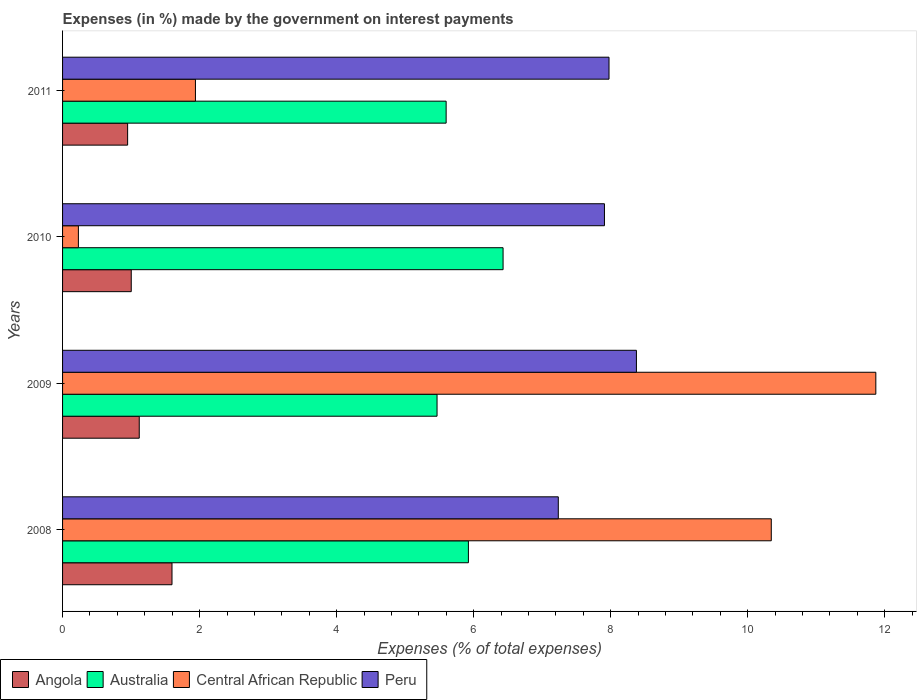Are the number of bars per tick equal to the number of legend labels?
Make the answer very short. Yes. How many bars are there on the 4th tick from the top?
Your response must be concise. 4. What is the percentage of expenses made by the government on interest payments in Angola in 2009?
Provide a succinct answer. 1.12. Across all years, what is the maximum percentage of expenses made by the government on interest payments in Angola?
Your response must be concise. 1.6. Across all years, what is the minimum percentage of expenses made by the government on interest payments in Central African Republic?
Offer a terse response. 0.23. In which year was the percentage of expenses made by the government on interest payments in Peru maximum?
Offer a very short reply. 2009. In which year was the percentage of expenses made by the government on interest payments in Australia minimum?
Give a very brief answer. 2009. What is the total percentage of expenses made by the government on interest payments in Central African Republic in the graph?
Your answer should be very brief. 24.38. What is the difference between the percentage of expenses made by the government on interest payments in Angola in 2010 and that in 2011?
Offer a very short reply. 0.05. What is the difference between the percentage of expenses made by the government on interest payments in Peru in 2010 and the percentage of expenses made by the government on interest payments in Australia in 2011?
Your answer should be very brief. 2.31. What is the average percentage of expenses made by the government on interest payments in Australia per year?
Provide a short and direct response. 5.85. In the year 2009, what is the difference between the percentage of expenses made by the government on interest payments in Central African Republic and percentage of expenses made by the government on interest payments in Australia?
Keep it short and to the point. 6.4. What is the ratio of the percentage of expenses made by the government on interest payments in Central African Republic in 2008 to that in 2010?
Your answer should be very brief. 44.79. Is the percentage of expenses made by the government on interest payments in Peru in 2008 less than that in 2011?
Your answer should be very brief. Yes. Is the difference between the percentage of expenses made by the government on interest payments in Central African Republic in 2009 and 2011 greater than the difference between the percentage of expenses made by the government on interest payments in Australia in 2009 and 2011?
Provide a short and direct response. Yes. What is the difference between the highest and the second highest percentage of expenses made by the government on interest payments in Central African Republic?
Your answer should be very brief. 1.53. What is the difference between the highest and the lowest percentage of expenses made by the government on interest payments in Australia?
Provide a succinct answer. 0.96. In how many years, is the percentage of expenses made by the government on interest payments in Peru greater than the average percentage of expenses made by the government on interest payments in Peru taken over all years?
Ensure brevity in your answer.  3. Is it the case that in every year, the sum of the percentage of expenses made by the government on interest payments in Peru and percentage of expenses made by the government on interest payments in Australia is greater than the sum of percentage of expenses made by the government on interest payments in Angola and percentage of expenses made by the government on interest payments in Central African Republic?
Ensure brevity in your answer.  Yes. What does the 3rd bar from the top in 2008 represents?
Your answer should be very brief. Australia. What does the 4th bar from the bottom in 2008 represents?
Ensure brevity in your answer.  Peru. Are all the bars in the graph horizontal?
Provide a short and direct response. Yes. How many years are there in the graph?
Provide a short and direct response. 4. What is the difference between two consecutive major ticks on the X-axis?
Give a very brief answer. 2. Are the values on the major ticks of X-axis written in scientific E-notation?
Ensure brevity in your answer.  No. Where does the legend appear in the graph?
Provide a succinct answer. Bottom left. What is the title of the graph?
Ensure brevity in your answer.  Expenses (in %) made by the government on interest payments. Does "Lower middle income" appear as one of the legend labels in the graph?
Your answer should be compact. No. What is the label or title of the X-axis?
Your response must be concise. Expenses (% of total expenses). What is the label or title of the Y-axis?
Give a very brief answer. Years. What is the Expenses (% of total expenses) of Angola in 2008?
Your answer should be compact. 1.6. What is the Expenses (% of total expenses) of Australia in 2008?
Ensure brevity in your answer.  5.92. What is the Expenses (% of total expenses) in Central African Republic in 2008?
Your response must be concise. 10.34. What is the Expenses (% of total expenses) in Peru in 2008?
Your answer should be very brief. 7.24. What is the Expenses (% of total expenses) of Angola in 2009?
Your answer should be very brief. 1.12. What is the Expenses (% of total expenses) of Australia in 2009?
Offer a very short reply. 5.47. What is the Expenses (% of total expenses) in Central African Republic in 2009?
Keep it short and to the point. 11.87. What is the Expenses (% of total expenses) in Peru in 2009?
Provide a succinct answer. 8.38. What is the Expenses (% of total expenses) in Angola in 2010?
Offer a terse response. 1. What is the Expenses (% of total expenses) in Australia in 2010?
Provide a succinct answer. 6.43. What is the Expenses (% of total expenses) in Central African Republic in 2010?
Make the answer very short. 0.23. What is the Expenses (% of total expenses) of Peru in 2010?
Give a very brief answer. 7.91. What is the Expenses (% of total expenses) in Angola in 2011?
Your answer should be compact. 0.95. What is the Expenses (% of total expenses) of Australia in 2011?
Make the answer very short. 5.6. What is the Expenses (% of total expenses) of Central African Republic in 2011?
Make the answer very short. 1.94. What is the Expenses (% of total expenses) of Peru in 2011?
Offer a terse response. 7.98. Across all years, what is the maximum Expenses (% of total expenses) in Angola?
Offer a very short reply. 1.6. Across all years, what is the maximum Expenses (% of total expenses) of Australia?
Provide a succinct answer. 6.43. Across all years, what is the maximum Expenses (% of total expenses) of Central African Republic?
Your answer should be very brief. 11.87. Across all years, what is the maximum Expenses (% of total expenses) of Peru?
Your answer should be very brief. 8.38. Across all years, what is the minimum Expenses (% of total expenses) of Angola?
Make the answer very short. 0.95. Across all years, what is the minimum Expenses (% of total expenses) in Australia?
Your answer should be compact. 5.47. Across all years, what is the minimum Expenses (% of total expenses) of Central African Republic?
Keep it short and to the point. 0.23. Across all years, what is the minimum Expenses (% of total expenses) in Peru?
Your answer should be very brief. 7.24. What is the total Expenses (% of total expenses) in Angola in the graph?
Offer a very short reply. 4.67. What is the total Expenses (% of total expenses) in Australia in the graph?
Make the answer very short. 23.42. What is the total Expenses (% of total expenses) of Central African Republic in the graph?
Provide a succinct answer. 24.38. What is the total Expenses (% of total expenses) in Peru in the graph?
Give a very brief answer. 31.5. What is the difference between the Expenses (% of total expenses) in Angola in 2008 and that in 2009?
Ensure brevity in your answer.  0.48. What is the difference between the Expenses (% of total expenses) in Australia in 2008 and that in 2009?
Keep it short and to the point. 0.46. What is the difference between the Expenses (% of total expenses) in Central African Republic in 2008 and that in 2009?
Offer a terse response. -1.53. What is the difference between the Expenses (% of total expenses) in Peru in 2008 and that in 2009?
Your answer should be very brief. -1.14. What is the difference between the Expenses (% of total expenses) of Angola in 2008 and that in 2010?
Provide a short and direct response. 0.59. What is the difference between the Expenses (% of total expenses) of Australia in 2008 and that in 2010?
Provide a succinct answer. -0.51. What is the difference between the Expenses (% of total expenses) of Central African Republic in 2008 and that in 2010?
Make the answer very short. 10.11. What is the difference between the Expenses (% of total expenses) in Peru in 2008 and that in 2010?
Your response must be concise. -0.67. What is the difference between the Expenses (% of total expenses) of Angola in 2008 and that in 2011?
Keep it short and to the point. 0.65. What is the difference between the Expenses (% of total expenses) in Australia in 2008 and that in 2011?
Offer a terse response. 0.33. What is the difference between the Expenses (% of total expenses) of Central African Republic in 2008 and that in 2011?
Your answer should be compact. 8.4. What is the difference between the Expenses (% of total expenses) in Peru in 2008 and that in 2011?
Offer a very short reply. -0.74. What is the difference between the Expenses (% of total expenses) of Angola in 2009 and that in 2010?
Provide a succinct answer. 0.12. What is the difference between the Expenses (% of total expenses) in Australia in 2009 and that in 2010?
Your response must be concise. -0.96. What is the difference between the Expenses (% of total expenses) of Central African Republic in 2009 and that in 2010?
Keep it short and to the point. 11.64. What is the difference between the Expenses (% of total expenses) of Peru in 2009 and that in 2010?
Your response must be concise. 0.47. What is the difference between the Expenses (% of total expenses) in Angola in 2009 and that in 2011?
Ensure brevity in your answer.  0.17. What is the difference between the Expenses (% of total expenses) of Australia in 2009 and that in 2011?
Offer a very short reply. -0.13. What is the difference between the Expenses (% of total expenses) in Central African Republic in 2009 and that in 2011?
Keep it short and to the point. 9.93. What is the difference between the Expenses (% of total expenses) of Peru in 2009 and that in 2011?
Offer a very short reply. 0.4. What is the difference between the Expenses (% of total expenses) in Angola in 2010 and that in 2011?
Your answer should be compact. 0.05. What is the difference between the Expenses (% of total expenses) of Australia in 2010 and that in 2011?
Offer a very short reply. 0.83. What is the difference between the Expenses (% of total expenses) in Central African Republic in 2010 and that in 2011?
Your response must be concise. -1.71. What is the difference between the Expenses (% of total expenses) of Peru in 2010 and that in 2011?
Keep it short and to the point. -0.07. What is the difference between the Expenses (% of total expenses) of Angola in 2008 and the Expenses (% of total expenses) of Australia in 2009?
Your answer should be compact. -3.87. What is the difference between the Expenses (% of total expenses) in Angola in 2008 and the Expenses (% of total expenses) in Central African Republic in 2009?
Ensure brevity in your answer.  -10.27. What is the difference between the Expenses (% of total expenses) in Angola in 2008 and the Expenses (% of total expenses) in Peru in 2009?
Provide a short and direct response. -6.78. What is the difference between the Expenses (% of total expenses) in Australia in 2008 and the Expenses (% of total expenses) in Central African Republic in 2009?
Your answer should be compact. -5.95. What is the difference between the Expenses (% of total expenses) in Australia in 2008 and the Expenses (% of total expenses) in Peru in 2009?
Keep it short and to the point. -2.45. What is the difference between the Expenses (% of total expenses) of Central African Republic in 2008 and the Expenses (% of total expenses) of Peru in 2009?
Provide a succinct answer. 1.97. What is the difference between the Expenses (% of total expenses) in Angola in 2008 and the Expenses (% of total expenses) in Australia in 2010?
Your response must be concise. -4.83. What is the difference between the Expenses (% of total expenses) in Angola in 2008 and the Expenses (% of total expenses) in Central African Republic in 2010?
Make the answer very short. 1.37. What is the difference between the Expenses (% of total expenses) in Angola in 2008 and the Expenses (% of total expenses) in Peru in 2010?
Provide a succinct answer. -6.31. What is the difference between the Expenses (% of total expenses) of Australia in 2008 and the Expenses (% of total expenses) of Central African Republic in 2010?
Offer a terse response. 5.69. What is the difference between the Expenses (% of total expenses) of Australia in 2008 and the Expenses (% of total expenses) of Peru in 2010?
Provide a succinct answer. -1.99. What is the difference between the Expenses (% of total expenses) of Central African Republic in 2008 and the Expenses (% of total expenses) of Peru in 2010?
Make the answer very short. 2.43. What is the difference between the Expenses (% of total expenses) in Angola in 2008 and the Expenses (% of total expenses) in Australia in 2011?
Your answer should be very brief. -4. What is the difference between the Expenses (% of total expenses) of Angola in 2008 and the Expenses (% of total expenses) of Central African Republic in 2011?
Your answer should be very brief. -0.34. What is the difference between the Expenses (% of total expenses) of Angola in 2008 and the Expenses (% of total expenses) of Peru in 2011?
Provide a succinct answer. -6.38. What is the difference between the Expenses (% of total expenses) of Australia in 2008 and the Expenses (% of total expenses) of Central African Republic in 2011?
Give a very brief answer. 3.98. What is the difference between the Expenses (% of total expenses) in Australia in 2008 and the Expenses (% of total expenses) in Peru in 2011?
Give a very brief answer. -2.05. What is the difference between the Expenses (% of total expenses) of Central African Republic in 2008 and the Expenses (% of total expenses) of Peru in 2011?
Offer a very short reply. 2.37. What is the difference between the Expenses (% of total expenses) of Angola in 2009 and the Expenses (% of total expenses) of Australia in 2010?
Offer a terse response. -5.31. What is the difference between the Expenses (% of total expenses) in Angola in 2009 and the Expenses (% of total expenses) in Central African Republic in 2010?
Keep it short and to the point. 0.89. What is the difference between the Expenses (% of total expenses) of Angola in 2009 and the Expenses (% of total expenses) of Peru in 2010?
Give a very brief answer. -6.79. What is the difference between the Expenses (% of total expenses) in Australia in 2009 and the Expenses (% of total expenses) in Central African Republic in 2010?
Make the answer very short. 5.23. What is the difference between the Expenses (% of total expenses) in Australia in 2009 and the Expenses (% of total expenses) in Peru in 2010?
Your answer should be compact. -2.44. What is the difference between the Expenses (% of total expenses) of Central African Republic in 2009 and the Expenses (% of total expenses) of Peru in 2010?
Your answer should be compact. 3.96. What is the difference between the Expenses (% of total expenses) in Angola in 2009 and the Expenses (% of total expenses) in Australia in 2011?
Keep it short and to the point. -4.48. What is the difference between the Expenses (% of total expenses) in Angola in 2009 and the Expenses (% of total expenses) in Central African Republic in 2011?
Keep it short and to the point. -0.82. What is the difference between the Expenses (% of total expenses) of Angola in 2009 and the Expenses (% of total expenses) of Peru in 2011?
Provide a short and direct response. -6.86. What is the difference between the Expenses (% of total expenses) in Australia in 2009 and the Expenses (% of total expenses) in Central African Republic in 2011?
Keep it short and to the point. 3.53. What is the difference between the Expenses (% of total expenses) of Australia in 2009 and the Expenses (% of total expenses) of Peru in 2011?
Make the answer very short. -2.51. What is the difference between the Expenses (% of total expenses) of Central African Republic in 2009 and the Expenses (% of total expenses) of Peru in 2011?
Your answer should be very brief. 3.89. What is the difference between the Expenses (% of total expenses) of Angola in 2010 and the Expenses (% of total expenses) of Australia in 2011?
Your answer should be compact. -4.6. What is the difference between the Expenses (% of total expenses) in Angola in 2010 and the Expenses (% of total expenses) in Central African Republic in 2011?
Your response must be concise. -0.94. What is the difference between the Expenses (% of total expenses) of Angola in 2010 and the Expenses (% of total expenses) of Peru in 2011?
Your answer should be compact. -6.97. What is the difference between the Expenses (% of total expenses) of Australia in 2010 and the Expenses (% of total expenses) of Central African Republic in 2011?
Offer a terse response. 4.49. What is the difference between the Expenses (% of total expenses) in Australia in 2010 and the Expenses (% of total expenses) in Peru in 2011?
Your response must be concise. -1.55. What is the difference between the Expenses (% of total expenses) of Central African Republic in 2010 and the Expenses (% of total expenses) of Peru in 2011?
Your answer should be very brief. -7.74. What is the average Expenses (% of total expenses) of Angola per year?
Keep it short and to the point. 1.17. What is the average Expenses (% of total expenses) of Australia per year?
Provide a short and direct response. 5.85. What is the average Expenses (% of total expenses) in Central African Republic per year?
Provide a short and direct response. 6.1. What is the average Expenses (% of total expenses) of Peru per year?
Your answer should be compact. 7.87. In the year 2008, what is the difference between the Expenses (% of total expenses) of Angola and Expenses (% of total expenses) of Australia?
Your response must be concise. -4.33. In the year 2008, what is the difference between the Expenses (% of total expenses) of Angola and Expenses (% of total expenses) of Central African Republic?
Offer a terse response. -8.75. In the year 2008, what is the difference between the Expenses (% of total expenses) of Angola and Expenses (% of total expenses) of Peru?
Offer a very short reply. -5.64. In the year 2008, what is the difference between the Expenses (% of total expenses) in Australia and Expenses (% of total expenses) in Central African Republic?
Provide a short and direct response. -4.42. In the year 2008, what is the difference between the Expenses (% of total expenses) of Australia and Expenses (% of total expenses) of Peru?
Make the answer very short. -1.31. In the year 2008, what is the difference between the Expenses (% of total expenses) of Central African Republic and Expenses (% of total expenses) of Peru?
Make the answer very short. 3.11. In the year 2009, what is the difference between the Expenses (% of total expenses) in Angola and Expenses (% of total expenses) in Australia?
Your response must be concise. -4.35. In the year 2009, what is the difference between the Expenses (% of total expenses) in Angola and Expenses (% of total expenses) in Central African Republic?
Ensure brevity in your answer.  -10.75. In the year 2009, what is the difference between the Expenses (% of total expenses) in Angola and Expenses (% of total expenses) in Peru?
Your answer should be very brief. -7.26. In the year 2009, what is the difference between the Expenses (% of total expenses) of Australia and Expenses (% of total expenses) of Central African Republic?
Provide a succinct answer. -6.4. In the year 2009, what is the difference between the Expenses (% of total expenses) in Australia and Expenses (% of total expenses) in Peru?
Your answer should be very brief. -2.91. In the year 2009, what is the difference between the Expenses (% of total expenses) of Central African Republic and Expenses (% of total expenses) of Peru?
Your answer should be very brief. 3.49. In the year 2010, what is the difference between the Expenses (% of total expenses) in Angola and Expenses (% of total expenses) in Australia?
Make the answer very short. -5.43. In the year 2010, what is the difference between the Expenses (% of total expenses) in Angola and Expenses (% of total expenses) in Central African Republic?
Offer a very short reply. 0.77. In the year 2010, what is the difference between the Expenses (% of total expenses) in Angola and Expenses (% of total expenses) in Peru?
Offer a terse response. -6.91. In the year 2010, what is the difference between the Expenses (% of total expenses) in Australia and Expenses (% of total expenses) in Central African Republic?
Your answer should be very brief. 6.2. In the year 2010, what is the difference between the Expenses (% of total expenses) of Australia and Expenses (% of total expenses) of Peru?
Give a very brief answer. -1.48. In the year 2010, what is the difference between the Expenses (% of total expenses) of Central African Republic and Expenses (% of total expenses) of Peru?
Your answer should be very brief. -7.68. In the year 2011, what is the difference between the Expenses (% of total expenses) in Angola and Expenses (% of total expenses) in Australia?
Your answer should be very brief. -4.65. In the year 2011, what is the difference between the Expenses (% of total expenses) in Angola and Expenses (% of total expenses) in Central African Republic?
Offer a very short reply. -0.99. In the year 2011, what is the difference between the Expenses (% of total expenses) in Angola and Expenses (% of total expenses) in Peru?
Your response must be concise. -7.03. In the year 2011, what is the difference between the Expenses (% of total expenses) of Australia and Expenses (% of total expenses) of Central African Republic?
Provide a succinct answer. 3.66. In the year 2011, what is the difference between the Expenses (% of total expenses) of Australia and Expenses (% of total expenses) of Peru?
Offer a very short reply. -2.38. In the year 2011, what is the difference between the Expenses (% of total expenses) of Central African Republic and Expenses (% of total expenses) of Peru?
Provide a short and direct response. -6.04. What is the ratio of the Expenses (% of total expenses) of Angola in 2008 to that in 2009?
Make the answer very short. 1.43. What is the ratio of the Expenses (% of total expenses) in Australia in 2008 to that in 2009?
Provide a succinct answer. 1.08. What is the ratio of the Expenses (% of total expenses) of Central African Republic in 2008 to that in 2009?
Ensure brevity in your answer.  0.87. What is the ratio of the Expenses (% of total expenses) in Peru in 2008 to that in 2009?
Give a very brief answer. 0.86. What is the ratio of the Expenses (% of total expenses) in Angola in 2008 to that in 2010?
Your answer should be compact. 1.59. What is the ratio of the Expenses (% of total expenses) of Australia in 2008 to that in 2010?
Ensure brevity in your answer.  0.92. What is the ratio of the Expenses (% of total expenses) in Central African Republic in 2008 to that in 2010?
Your answer should be compact. 44.79. What is the ratio of the Expenses (% of total expenses) in Peru in 2008 to that in 2010?
Ensure brevity in your answer.  0.91. What is the ratio of the Expenses (% of total expenses) in Angola in 2008 to that in 2011?
Give a very brief answer. 1.68. What is the ratio of the Expenses (% of total expenses) of Australia in 2008 to that in 2011?
Ensure brevity in your answer.  1.06. What is the ratio of the Expenses (% of total expenses) in Central African Republic in 2008 to that in 2011?
Provide a succinct answer. 5.33. What is the ratio of the Expenses (% of total expenses) in Peru in 2008 to that in 2011?
Ensure brevity in your answer.  0.91. What is the ratio of the Expenses (% of total expenses) of Angola in 2009 to that in 2010?
Your answer should be compact. 1.12. What is the ratio of the Expenses (% of total expenses) in Australia in 2009 to that in 2010?
Provide a succinct answer. 0.85. What is the ratio of the Expenses (% of total expenses) in Central African Republic in 2009 to that in 2010?
Your answer should be very brief. 51.4. What is the ratio of the Expenses (% of total expenses) of Peru in 2009 to that in 2010?
Your answer should be compact. 1.06. What is the ratio of the Expenses (% of total expenses) in Angola in 2009 to that in 2011?
Make the answer very short. 1.18. What is the ratio of the Expenses (% of total expenses) in Australia in 2009 to that in 2011?
Provide a short and direct response. 0.98. What is the ratio of the Expenses (% of total expenses) of Central African Republic in 2009 to that in 2011?
Offer a very short reply. 6.12. What is the ratio of the Expenses (% of total expenses) of Peru in 2009 to that in 2011?
Your answer should be compact. 1.05. What is the ratio of the Expenses (% of total expenses) of Angola in 2010 to that in 2011?
Make the answer very short. 1.06. What is the ratio of the Expenses (% of total expenses) of Australia in 2010 to that in 2011?
Offer a very short reply. 1.15. What is the ratio of the Expenses (% of total expenses) of Central African Republic in 2010 to that in 2011?
Ensure brevity in your answer.  0.12. What is the difference between the highest and the second highest Expenses (% of total expenses) in Angola?
Make the answer very short. 0.48. What is the difference between the highest and the second highest Expenses (% of total expenses) of Australia?
Your response must be concise. 0.51. What is the difference between the highest and the second highest Expenses (% of total expenses) of Central African Republic?
Make the answer very short. 1.53. What is the difference between the highest and the second highest Expenses (% of total expenses) of Peru?
Keep it short and to the point. 0.4. What is the difference between the highest and the lowest Expenses (% of total expenses) in Angola?
Your answer should be very brief. 0.65. What is the difference between the highest and the lowest Expenses (% of total expenses) of Australia?
Ensure brevity in your answer.  0.96. What is the difference between the highest and the lowest Expenses (% of total expenses) in Central African Republic?
Provide a succinct answer. 11.64. What is the difference between the highest and the lowest Expenses (% of total expenses) in Peru?
Offer a very short reply. 1.14. 